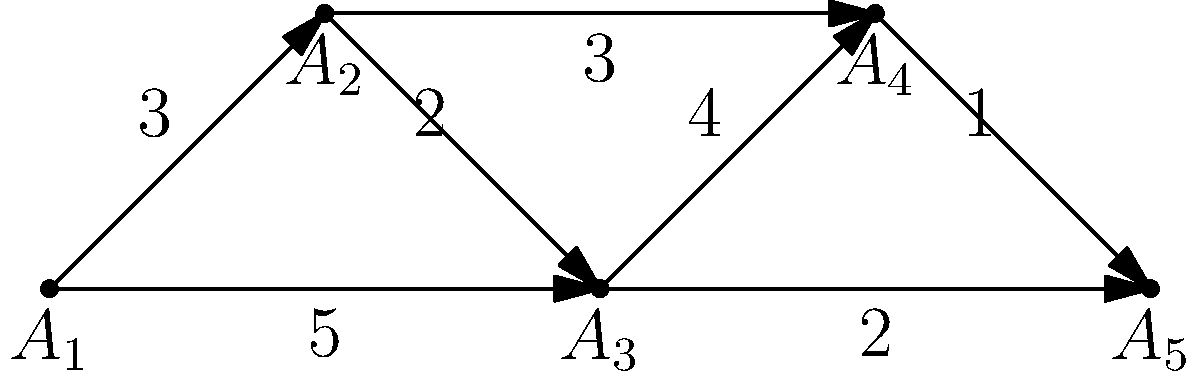In a Disney theme park, the directed graph represents the flow of visitors between attractions (A₁ to A₅). The edge weights indicate the average time (in minutes) it takes to move between attractions. What is the minimum time required to visit all attractions, starting from A₁ and ending at A₅, if a visitor must go through each attraction exactly once? To solve this problem, we need to find the shortest path that visits all attractions exactly once, starting from A₁ and ending at A₅. This is known as the Hamiltonian path problem.

Step 1: Identify all possible paths from A₁ to A₅ that visit each attraction once.
- Path 1: A₁ → A₂ → A₃ → A₄ → A₅
- Path 2: A₁ → A₂ → A₄ → A₃ → A₅
- Path 3: A₁ → A₃ → A₂ → A₄ → A₅
- Path 4: A₁ → A₃ → A₄ → A₂ → A₅

Step 2: Calculate the total time for each path.
- Path 1: 3 + 2 + 4 + 1 = 10 minutes
- Path 2: 3 + 3 + 4 + 2 = 12 minutes
- Path 3: 5 + 2 + 3 + 1 = 11 minutes
- Path 4: 5 + 4 + 3 + 1 = 13 minutes

Step 3: Identify the path with the minimum time.
The path with the minimum time is Path 1: A₁ → A₂ → A₃ → A₄ → A₅, which takes 10 minutes.

Therefore, the minimum time required to visit all attractions, starting from A₁ and ending at A₅, while going through each attraction exactly once is 10 minutes.
Answer: 10 minutes 